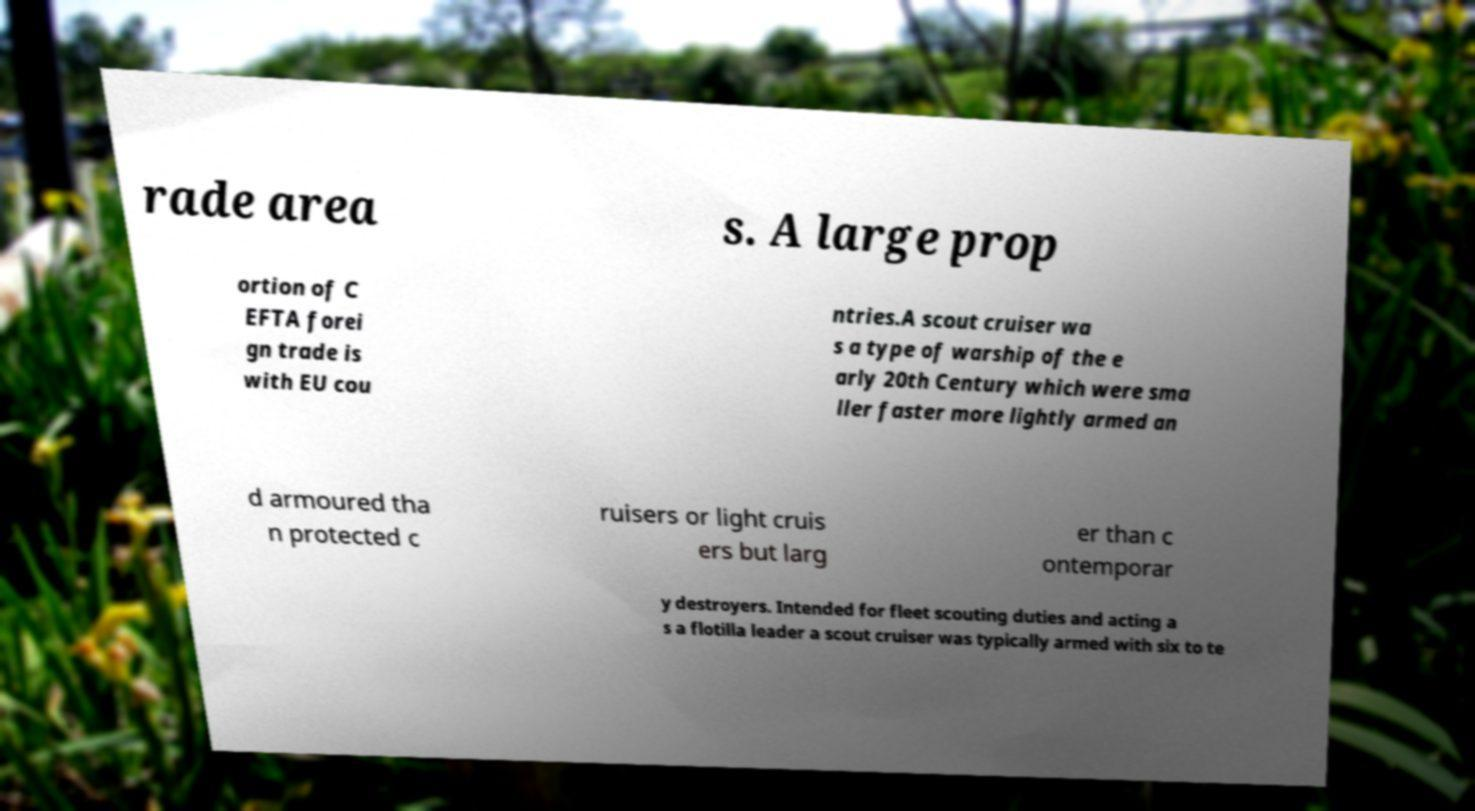Please identify and transcribe the text found in this image. rade area s. A large prop ortion of C EFTA forei gn trade is with EU cou ntries.A scout cruiser wa s a type of warship of the e arly 20th Century which were sma ller faster more lightly armed an d armoured tha n protected c ruisers or light cruis ers but larg er than c ontemporar y destroyers. Intended for fleet scouting duties and acting a s a flotilla leader a scout cruiser was typically armed with six to te 